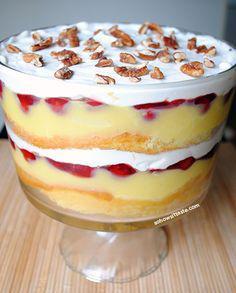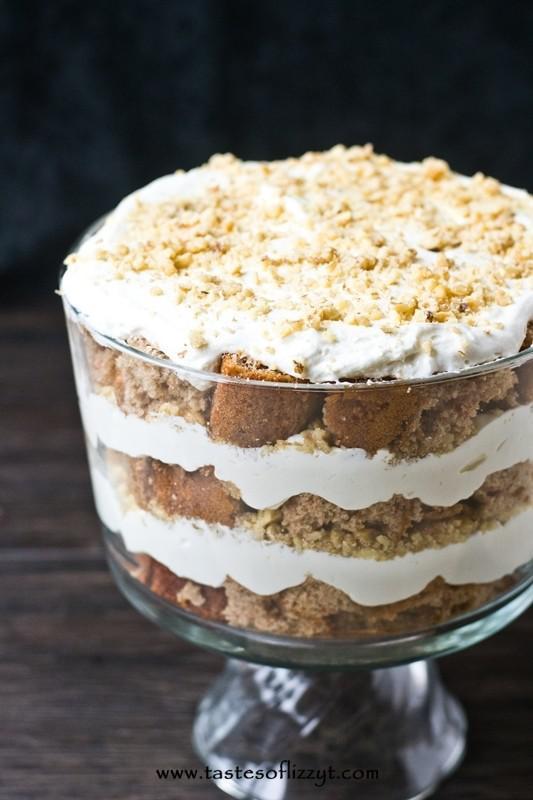The first image is the image on the left, the second image is the image on the right. Analyze the images presented: Is the assertion "Berries top a trifle in one image." valid? Answer yes or no. No. The first image is the image on the left, the second image is the image on the right. Considering the images on both sides, is "Part of some utensils are visible." valid? Answer yes or no. No. 